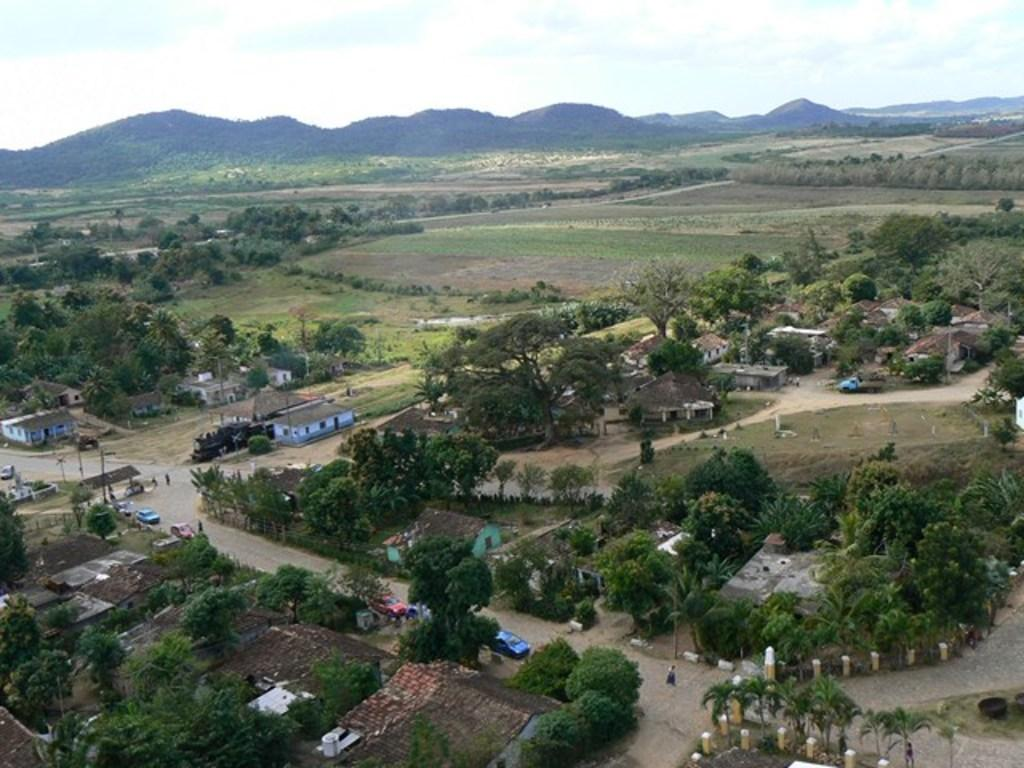What type of view is depicted in the image? The image is an aerial view. What structures can be seen in the image? There are houses in the image. What type of vegetation is present in the image? There are trees in the image. What type of transportation is visible in the image? There are cars on roads in the image. What type of landscape can be seen in the background of the image? There are fields and mountains in the background of the image. What part of the natural environment is visible in the image? The sky is visible in the image. What type of trouble can be seen in the image? There is no trouble depicted in the image; it shows an aerial view of houses, trees, cars, roads, fields, mountains, and the sky. What type of neck is visible in the image? There are no necks visible in the image. 